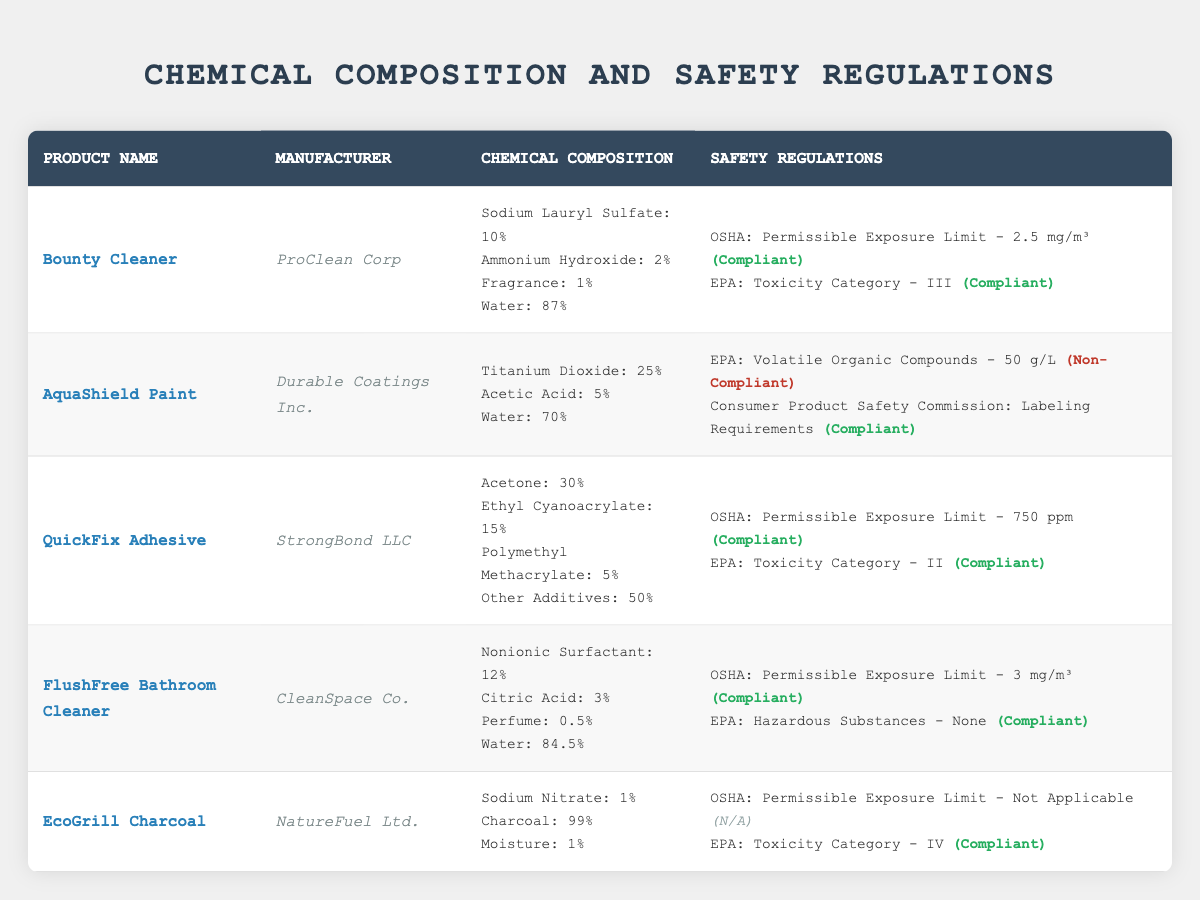What is the manufacturer of the FlushFree Bathroom Cleaner? The table lists the product names along with their manufacturers. Looking at the row for FlushFree Bathroom Cleaner, it shows "CleanSpace Co." as the manufacturer.
Answer: CleanSpace Co Which product has a non-compliant status according to the EPA? By checking the safety regulations of each product, AquaShield Paint is the only product marked as non-compliant with the status "Non-Compliant" under EPA.
Answer: AquaShield Paint What is the permissible exposure limit for QuickFix Adhesive according to OSHA? The table provides safety regulation details for each product. For QuickFix Adhesive, the OSHA permissible exposure limit is listed as "750 ppm".
Answer: 750 ppm How many different chemicals are present in the chemical composition of EcoGrill Charcoal? Observing the chemical composition of EcoGrill Charcoal, it lists three components: Sodium Nitrate (1%), Charcoal (99%), and Moisture (1%). Therefore, there are three chemicals in total.
Answer: 3 Are all safety regulations for Bounty Cleaner compliant? The compliance status for Bounty Cleaner under OSHA is "Compliant" and for EPA is also "Compliant", indicating that both safety regulations are met.
Answer: Yes What is the total percentage of water in the chemical compositions of AquaShield Paint and FlushFree Bathroom Cleaner? AquaShield Paint contains 70% water and FlushFree Bathroom Cleaner contains 84.5% water. Adding these together results in 70 + 84.5 = 154.5%.
Answer: 154.5% Which product has the highest proportion of an individual chemical in its composition? Reviewing the chemical compositions, QuickFix Adhesive contains 50% Other Additives, which is the highest proportion of any individual component across all products listed.
Answer: QuickFix Adhesive What is the difference between the toxicity categories of Bounty Cleaner and QuickFix Adhesive? Bounty Cleaner has a toxicity category of III, while QuickFix Adhesive has a toxicity category of II. In terms of categorization, the difference is 1 category (III to II).
Answer: 1 category 